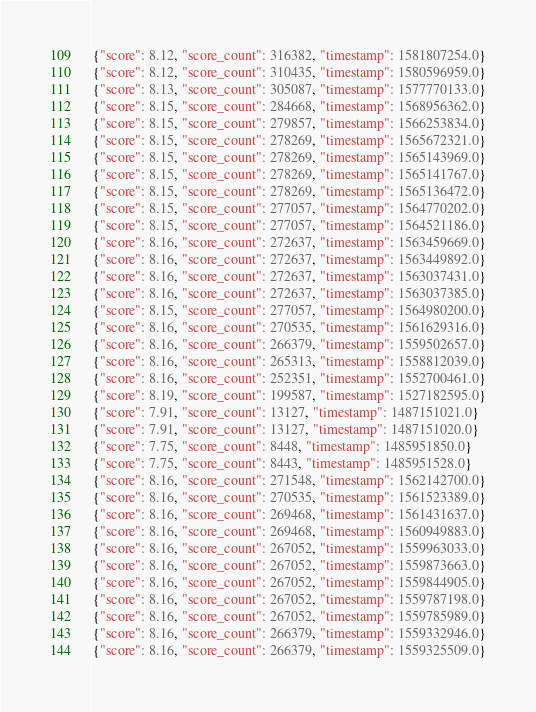Convert code to text. <code><loc_0><loc_0><loc_500><loc_500><_Julia_>{"score": 8.12, "score_count": 316382, "timestamp": 1581807254.0}
{"score": 8.12, "score_count": 310435, "timestamp": 1580596959.0}
{"score": 8.13, "score_count": 305087, "timestamp": 1577770133.0}
{"score": 8.15, "score_count": 284668, "timestamp": 1568956362.0}
{"score": 8.15, "score_count": 279857, "timestamp": 1566253834.0}
{"score": 8.15, "score_count": 278269, "timestamp": 1565672321.0}
{"score": 8.15, "score_count": 278269, "timestamp": 1565143969.0}
{"score": 8.15, "score_count": 278269, "timestamp": 1565141767.0}
{"score": 8.15, "score_count": 278269, "timestamp": 1565136472.0}
{"score": 8.15, "score_count": 277057, "timestamp": 1564770202.0}
{"score": 8.15, "score_count": 277057, "timestamp": 1564521186.0}
{"score": 8.16, "score_count": 272637, "timestamp": 1563459669.0}
{"score": 8.16, "score_count": 272637, "timestamp": 1563449892.0}
{"score": 8.16, "score_count": 272637, "timestamp": 1563037431.0}
{"score": 8.16, "score_count": 272637, "timestamp": 1563037385.0}
{"score": 8.15, "score_count": 277057, "timestamp": 1564980200.0}
{"score": 8.16, "score_count": 270535, "timestamp": 1561629316.0}
{"score": 8.16, "score_count": 266379, "timestamp": 1559502657.0}
{"score": 8.16, "score_count": 265313, "timestamp": 1558812039.0}
{"score": 8.16, "score_count": 252351, "timestamp": 1552700461.0}
{"score": 8.19, "score_count": 199587, "timestamp": 1527182595.0}
{"score": 7.91, "score_count": 13127, "timestamp": 1487151021.0}
{"score": 7.91, "score_count": 13127, "timestamp": 1487151020.0}
{"score": 7.75, "score_count": 8448, "timestamp": 1485951850.0}
{"score": 7.75, "score_count": 8443, "timestamp": 1485951528.0}
{"score": 8.16, "score_count": 271548, "timestamp": 1562142700.0}
{"score": 8.16, "score_count": 270535, "timestamp": 1561523389.0}
{"score": 8.16, "score_count": 269468, "timestamp": 1561431637.0}
{"score": 8.16, "score_count": 269468, "timestamp": 1560949883.0}
{"score": 8.16, "score_count": 267052, "timestamp": 1559963033.0}
{"score": 8.16, "score_count": 267052, "timestamp": 1559873663.0}
{"score": 8.16, "score_count": 267052, "timestamp": 1559844905.0}
{"score": 8.16, "score_count": 267052, "timestamp": 1559787198.0}
{"score": 8.16, "score_count": 267052, "timestamp": 1559785989.0}
{"score": 8.16, "score_count": 266379, "timestamp": 1559332946.0}
{"score": 8.16, "score_count": 266379, "timestamp": 1559325509.0}</code> 